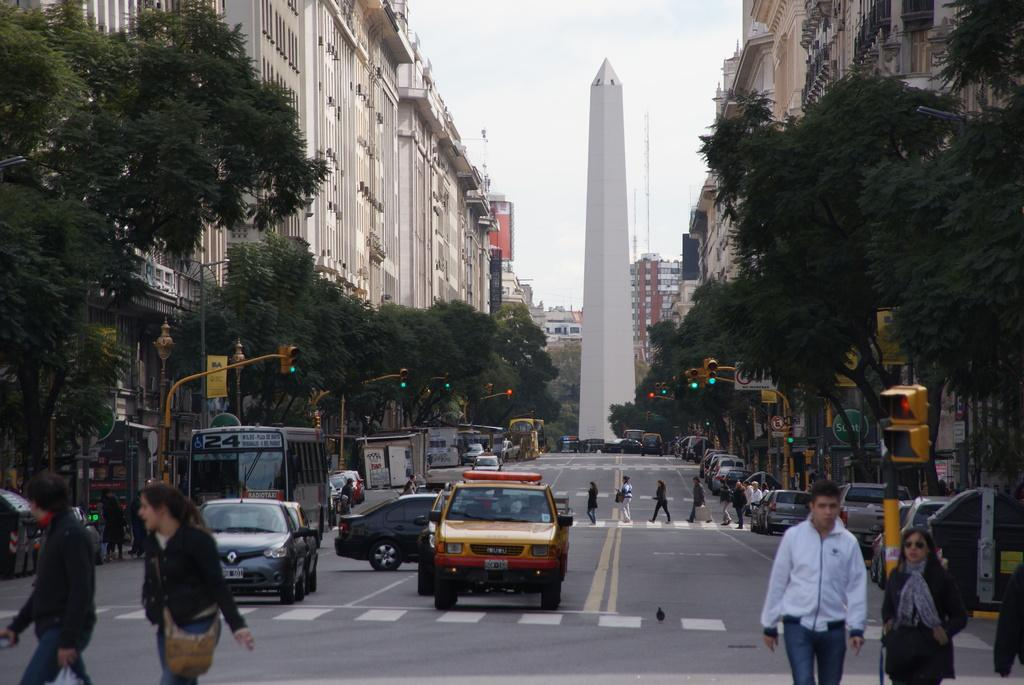What is happening on the road in the image? Vehicles are on the road, and people are on the road as well. What are the people doing on the road? People are walking on the road. What can be seen beside the road in the image? There are buildings and trees beside the road. What helps control traffic in the image? There are signal lights in the image. How many geese are walking with the people on the road? There are no geese present in the image; only people and vehicles are visible. Are the brothers in the image holding hands while walking on the road? There is no mention of brothers or anyone holding hands in the image; only people walking on the road are described. 